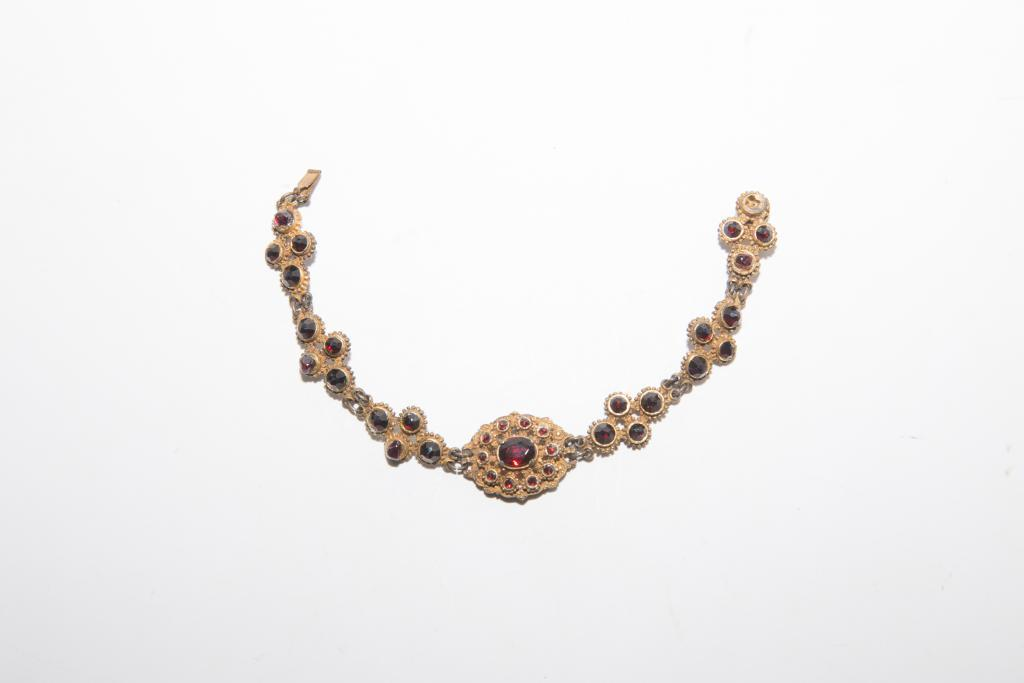What type of jewellery item is in the image? There is a necklace in the image. What is the color of the necklace? The necklace is in gold color. What are the kemples on the necklace made of? The kemples on the necklace are red in color. What is the background color of the image? The background of the image is white in color. What type of band is playing in the image? There is no band present in the image; it features a gold necklace with red kemples against a white background. 